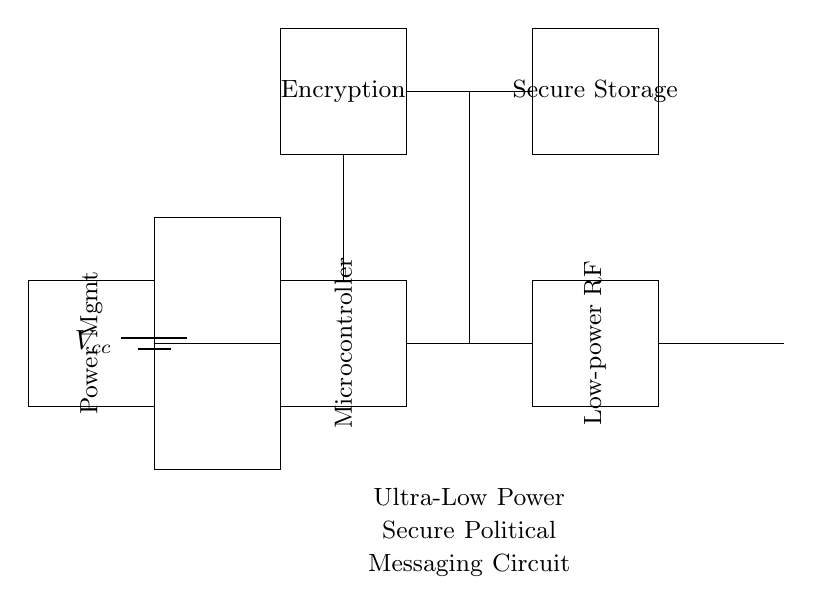What is the main component for secure messaging in this circuit? The main component for secure messaging is the encryption module, which processes the data before it is transmitted wirelessly.
Answer: encryption module What is the function of the low-power RF component? The low-power RF transceiver is responsible for enabling wireless communication, allowing the circuit to send and receive data securely over short distances.
Answer: wireless communication How many distinct modules are there in the circuit? The circuit includes five distinct modules: Power Management, Microcontroller, Encryption, Low-power RF, and Secure Storage, which together support the overall functionality of the circuit.
Answer: five What type of power supply is used in this circuit? The circuit uses a battery as the power supply, providing the necessary voltage for operation.
Answer: battery Which component is primarily responsible for managing power consumption? The power management module is primarily responsible for managing power consumption, optimizing the energy used by the circuit components.
Answer: power management What purpose does the secure storage module serve? The secure storage module is used to safely store sensitive data, ensuring that information is protected from unauthorized access before or after transmission.
Answer: safely store sensitive data How does the microcontroller interact with other components? The microcontroller orchestrates the operation of the circuit by controlling the data flow to and from the encryption module, communication with the RF transceiver, and managing inputs from the power management module.
Answer: orchestrates the operation 